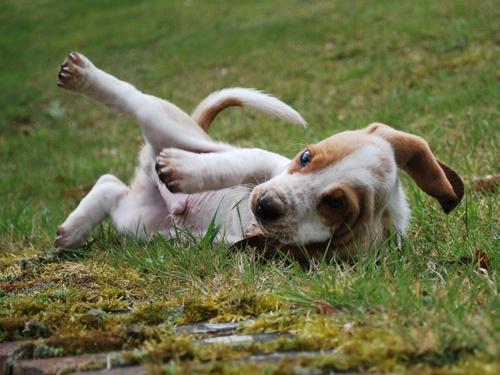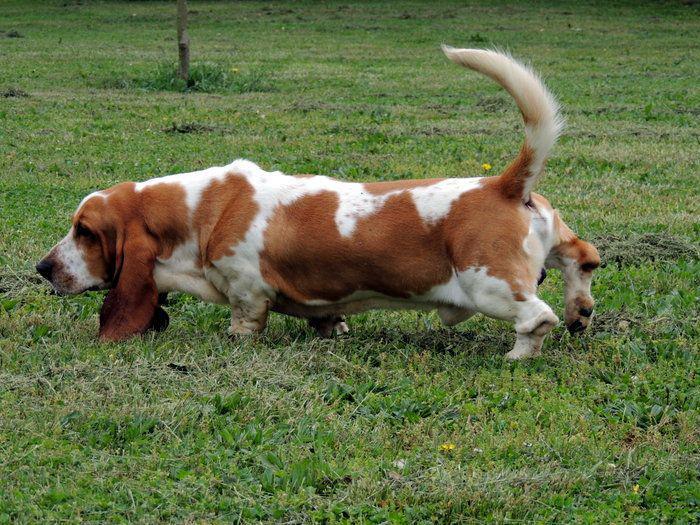The first image is the image on the left, the second image is the image on the right. Assess this claim about the two images: "Every dog on the left is young, every dog on the right is adult.". Correct or not? Answer yes or no. Yes. The first image is the image on the left, the second image is the image on the right. Considering the images on both sides, is "there is at least one puppy in the grass" valid? Answer yes or no. Yes. 